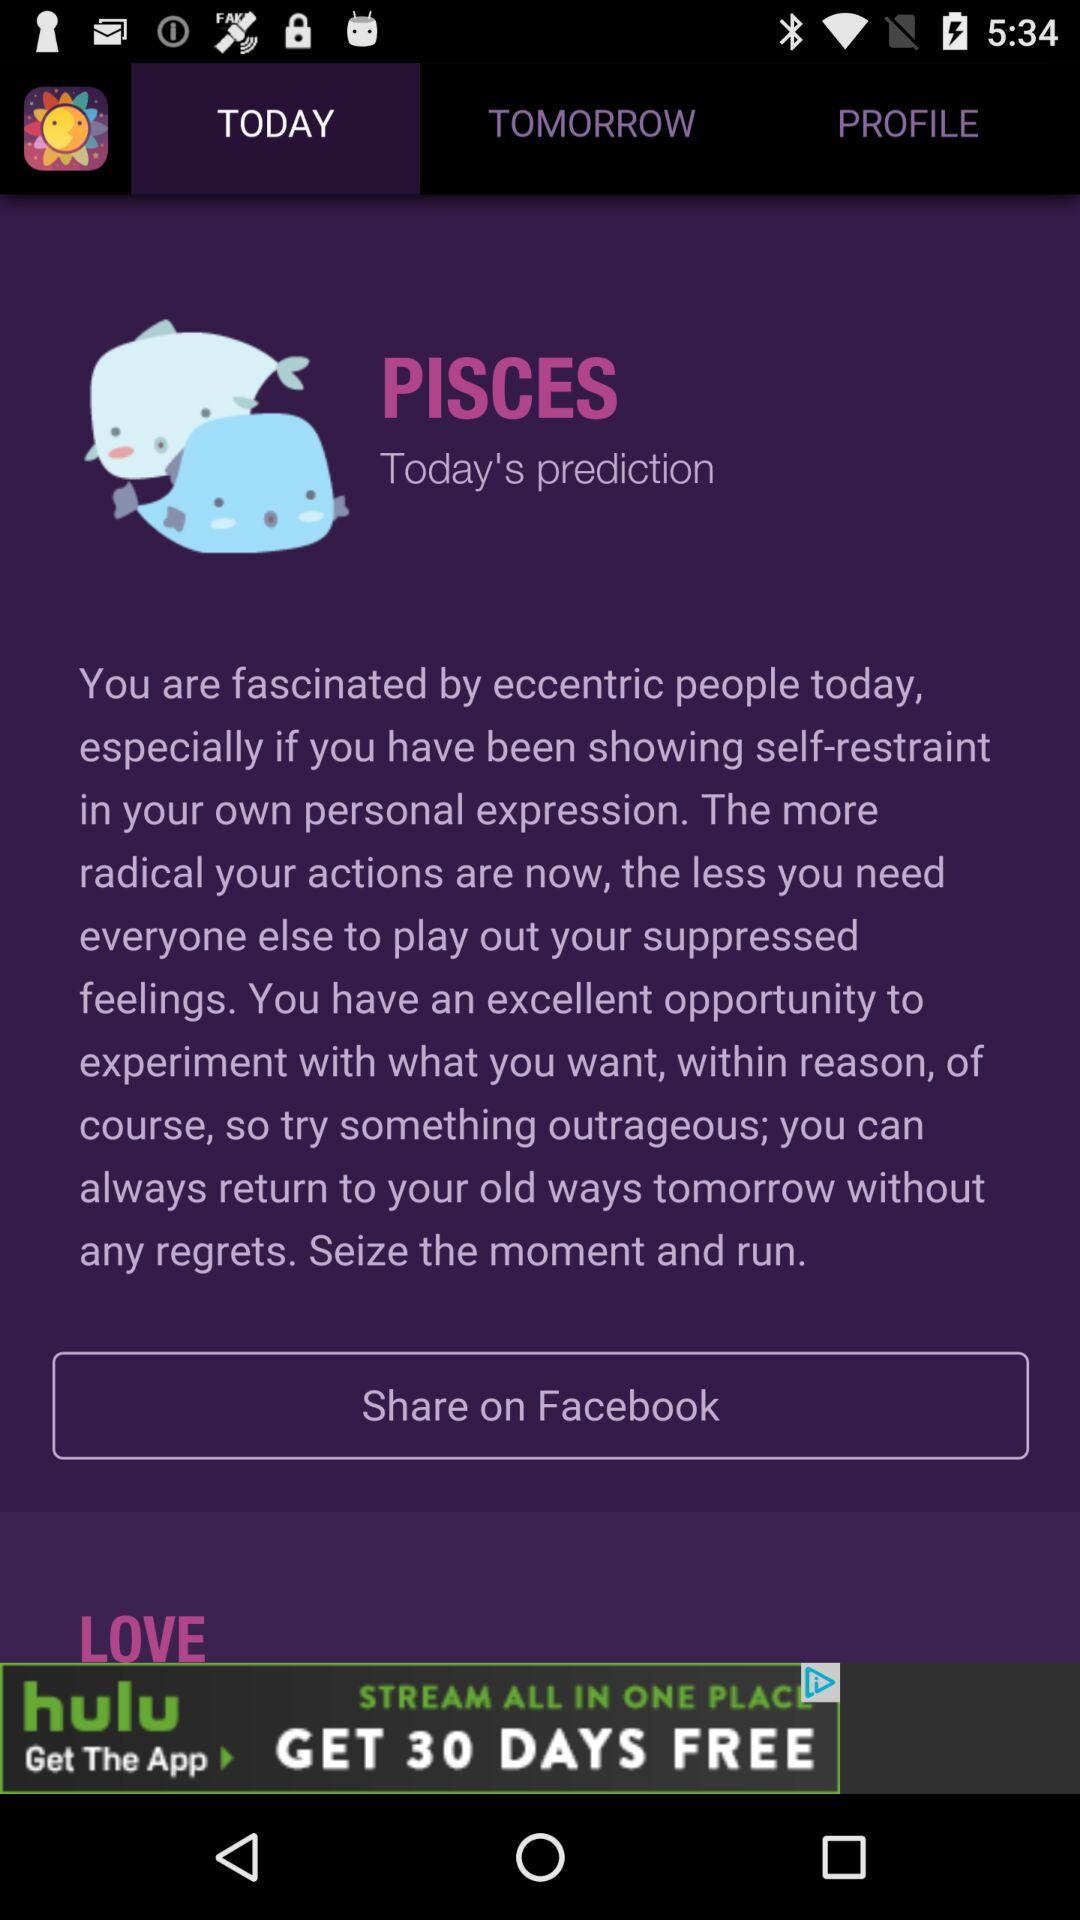What is tomorrow's prediction?
When the provided information is insufficient, respond with <no answer>. <no answer> 